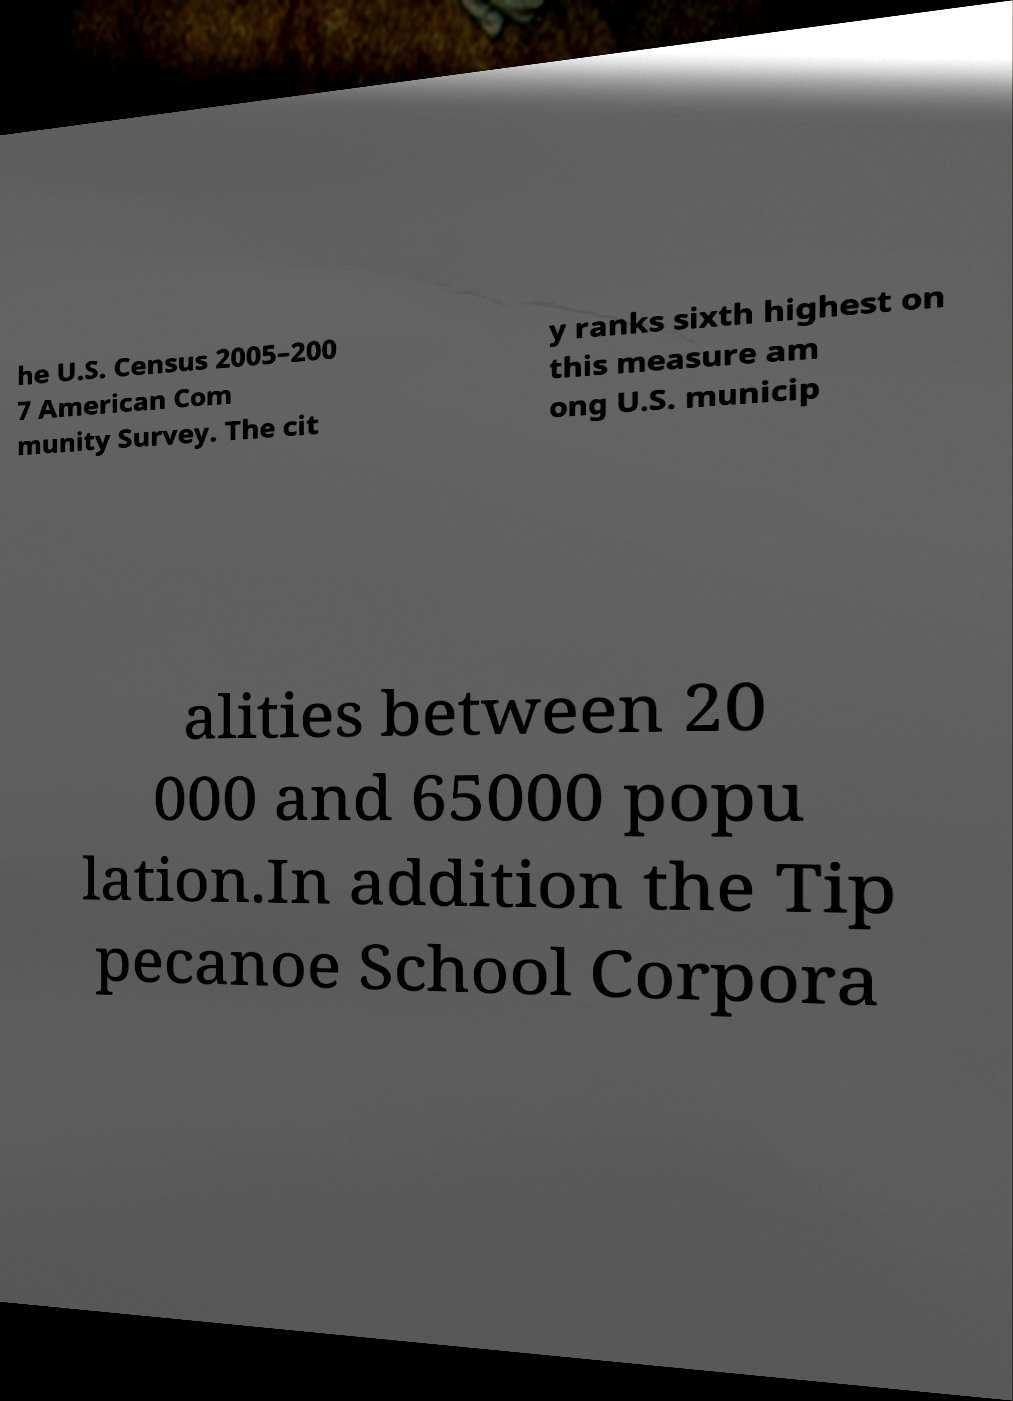I need the written content from this picture converted into text. Can you do that? he U.S. Census 2005–200 7 American Com munity Survey. The cit y ranks sixth highest on this measure am ong U.S. municip alities between 20 000 and 65000 popu lation.In addition the Tip pecanoe School Corpora 